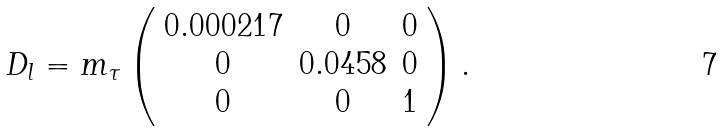Convert formula to latex. <formula><loc_0><loc_0><loc_500><loc_500>D _ { l } = m _ { \tau } \left ( \begin{array} { c c c } 0 . 0 0 0 2 1 7 & 0 & 0 \\ 0 & 0 . 0 4 5 8 & 0 \\ 0 & 0 & 1 \end{array} \right ) .</formula> 